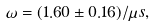Convert formula to latex. <formula><loc_0><loc_0><loc_500><loc_500>\omega = ( 1 . 6 0 \pm 0 . 1 6 ) / \mu s ,</formula> 